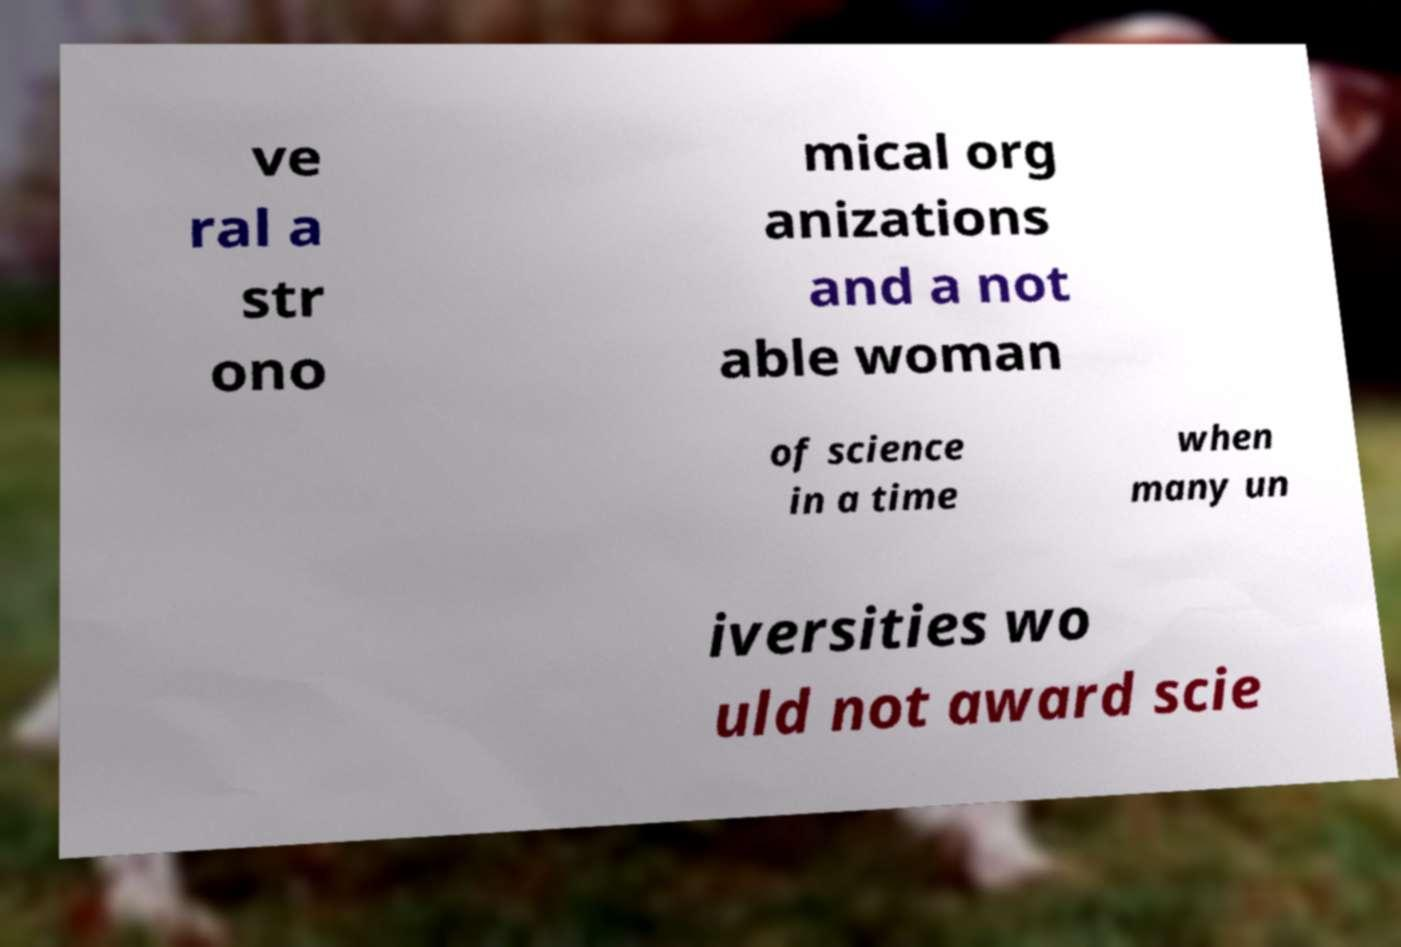Please identify and transcribe the text found in this image. ve ral a str ono mical org anizations and a not able woman of science in a time when many un iversities wo uld not award scie 